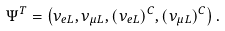Convert formula to latex. <formula><loc_0><loc_0><loc_500><loc_500>\Psi ^ { T } = \left ( \nu _ { e L } , \nu _ { \mu L } , ( \nu _ { e L } ) ^ { C } , ( \nu _ { \mu L } ) ^ { C } \right ) .</formula> 